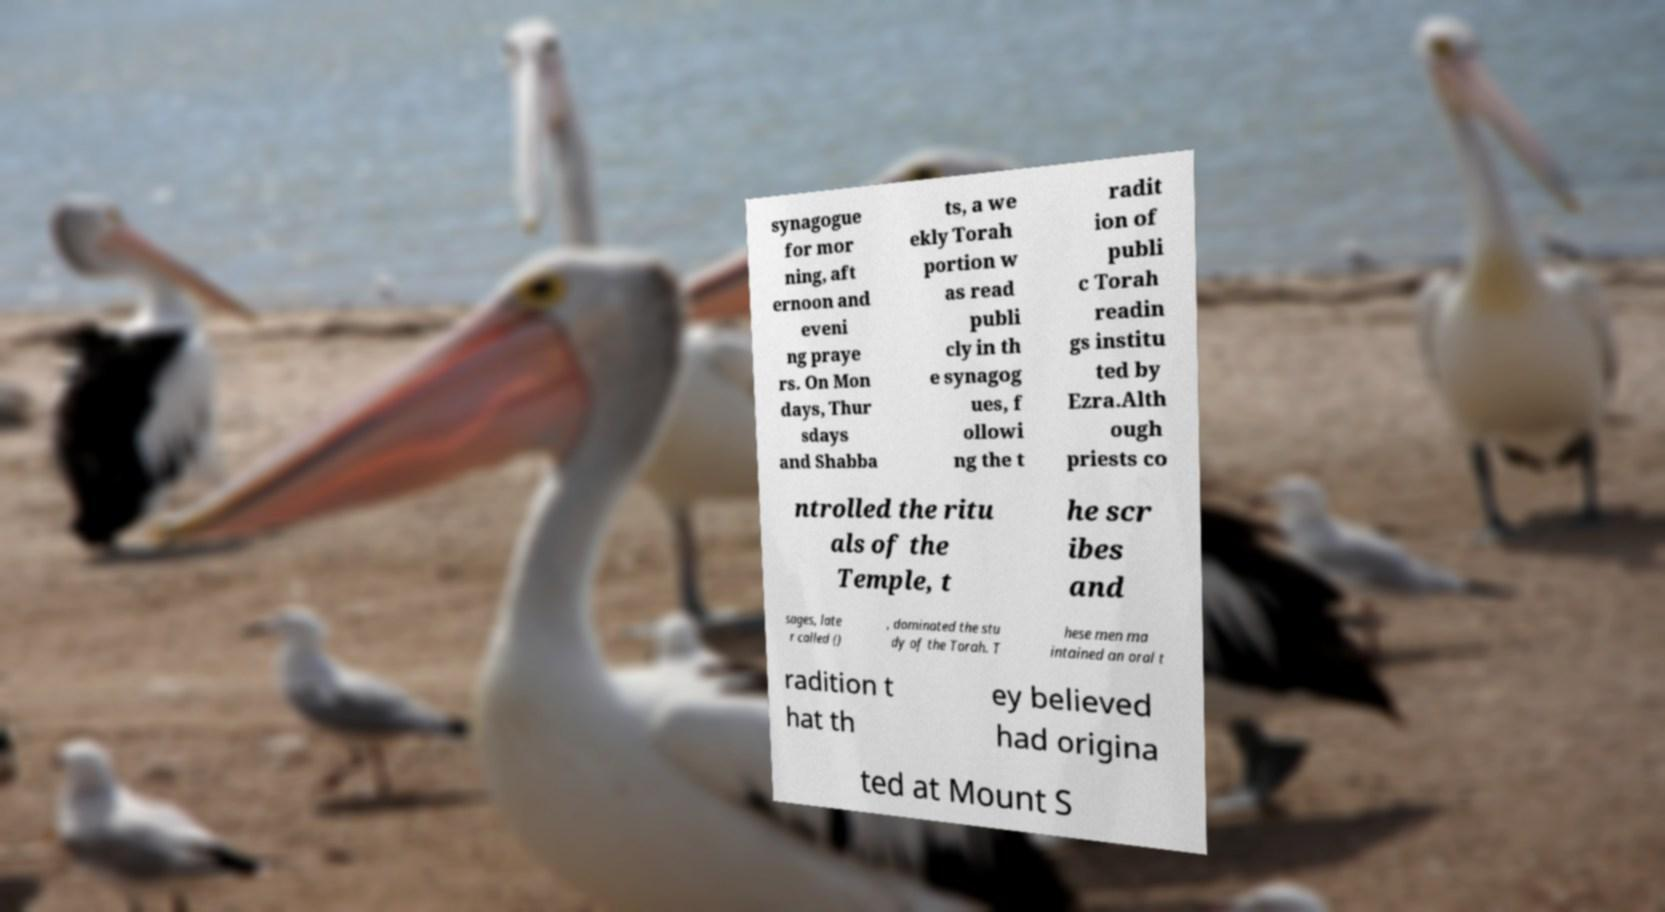Can you accurately transcribe the text from the provided image for me? synagogue for mor ning, aft ernoon and eveni ng praye rs. On Mon days, Thur sdays and Shabba ts, a we ekly Torah portion w as read publi cly in th e synagog ues, f ollowi ng the t radit ion of publi c Torah readin gs institu ted by Ezra.Alth ough priests co ntrolled the ritu als of the Temple, t he scr ibes and sages, late r called () , dominated the stu dy of the Torah. T hese men ma intained an oral t radition t hat th ey believed had origina ted at Mount S 